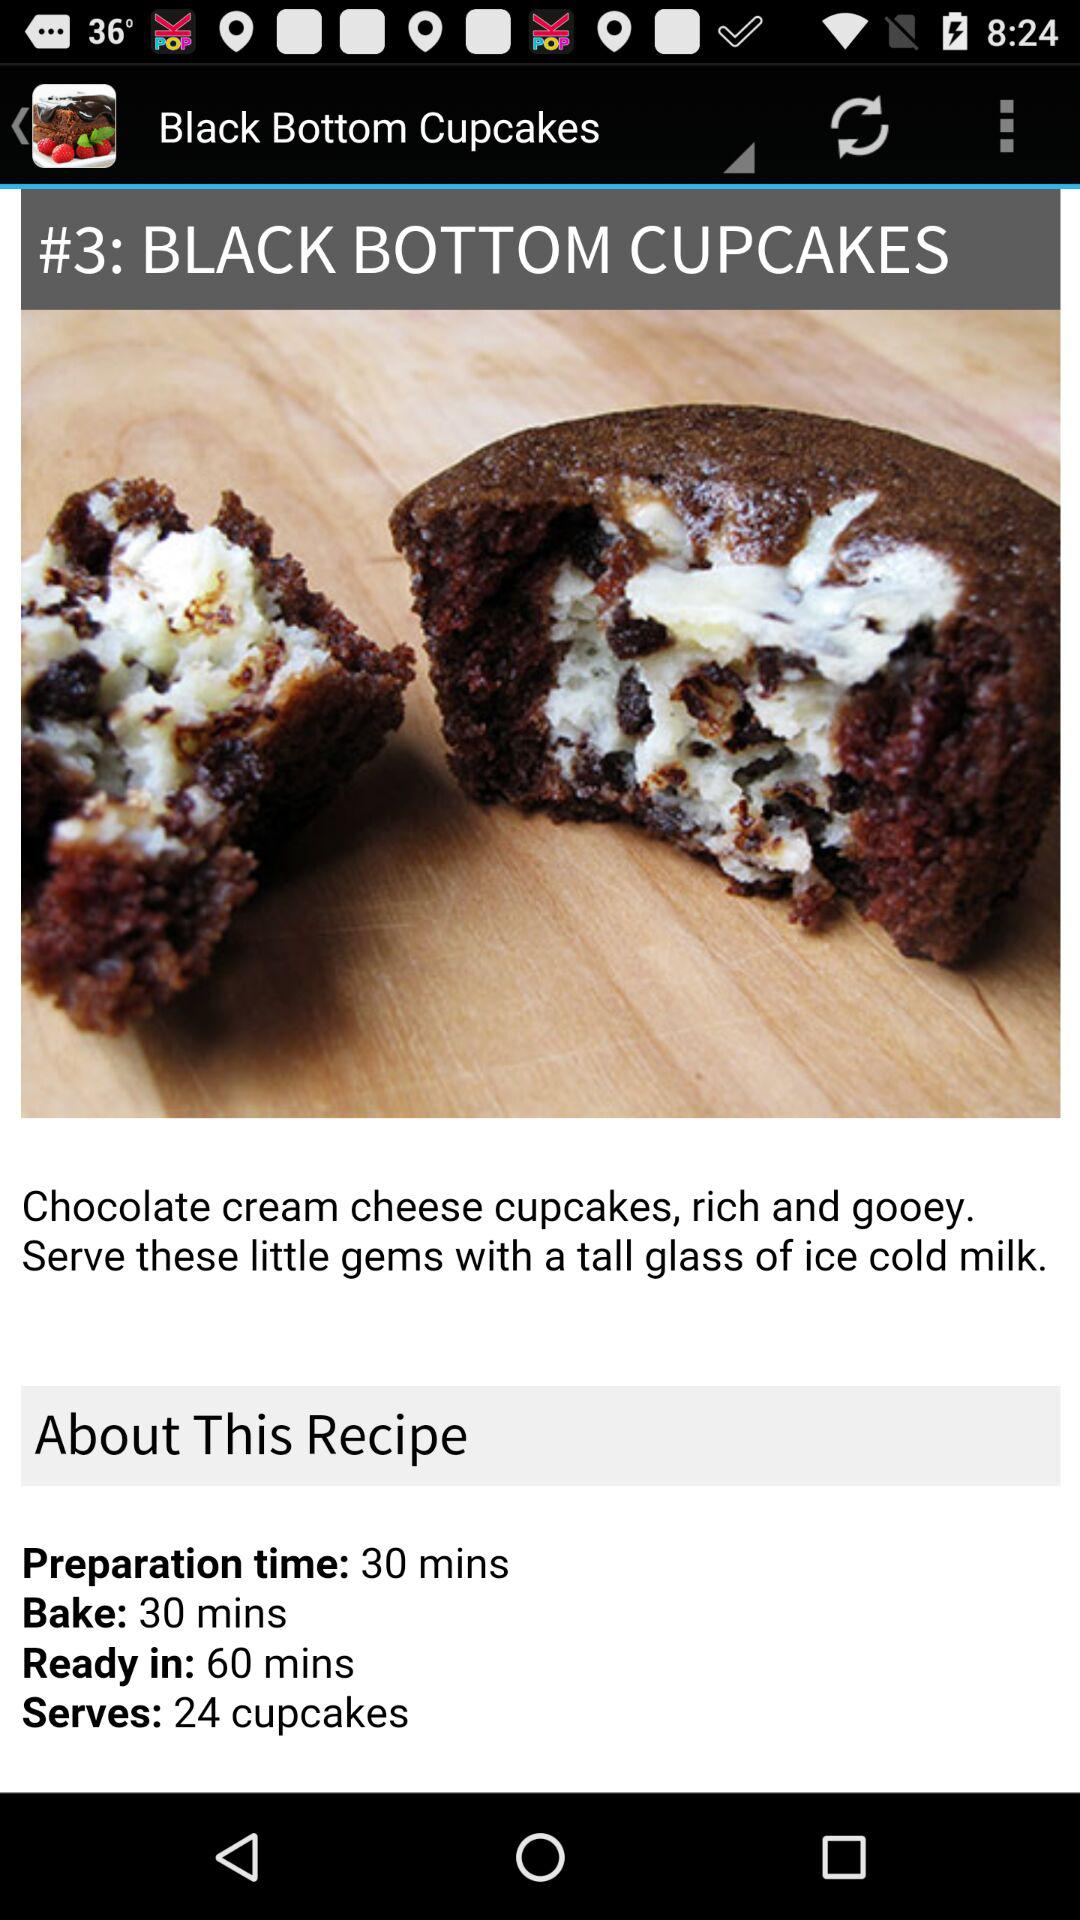What's the baking time? The baking time is 30 minutes. 